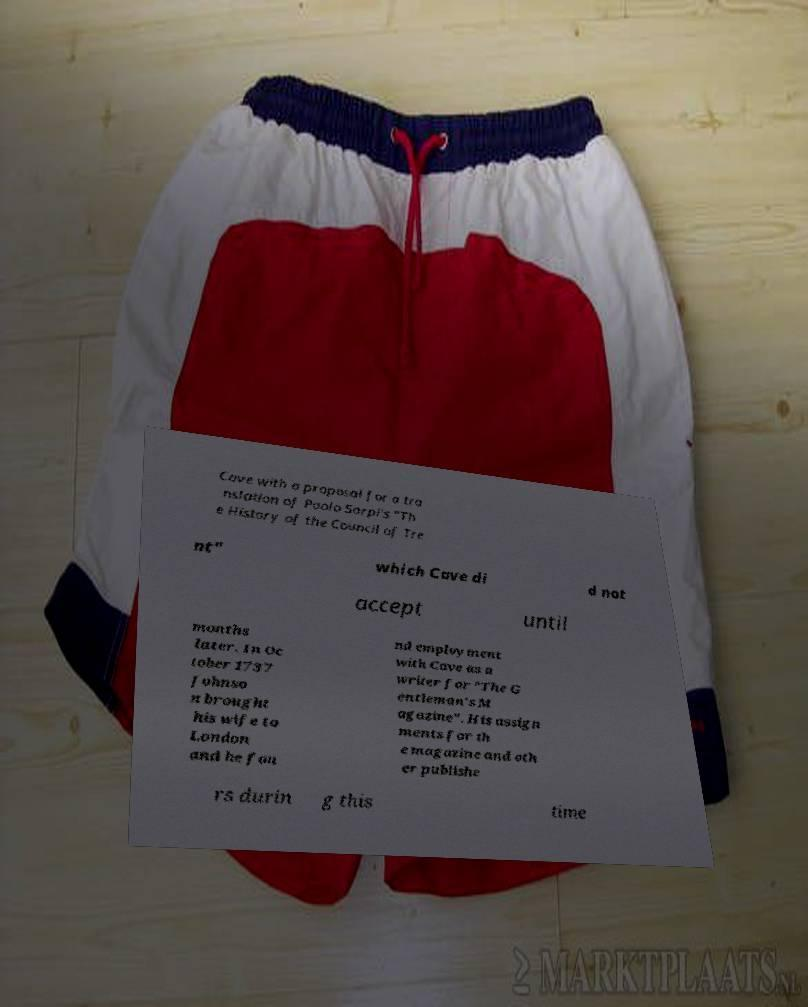Can you read and provide the text displayed in the image?This photo seems to have some interesting text. Can you extract and type it out for me? Cave with a proposal for a tra nslation of Paolo Sarpi's "Th e History of the Council of Tre nt" which Cave di d not accept until months later. In Oc tober 1737 Johnso n brought his wife to London and he fou nd employment with Cave as a writer for "The G entleman's M agazine". His assign ments for th e magazine and oth er publishe rs durin g this time 